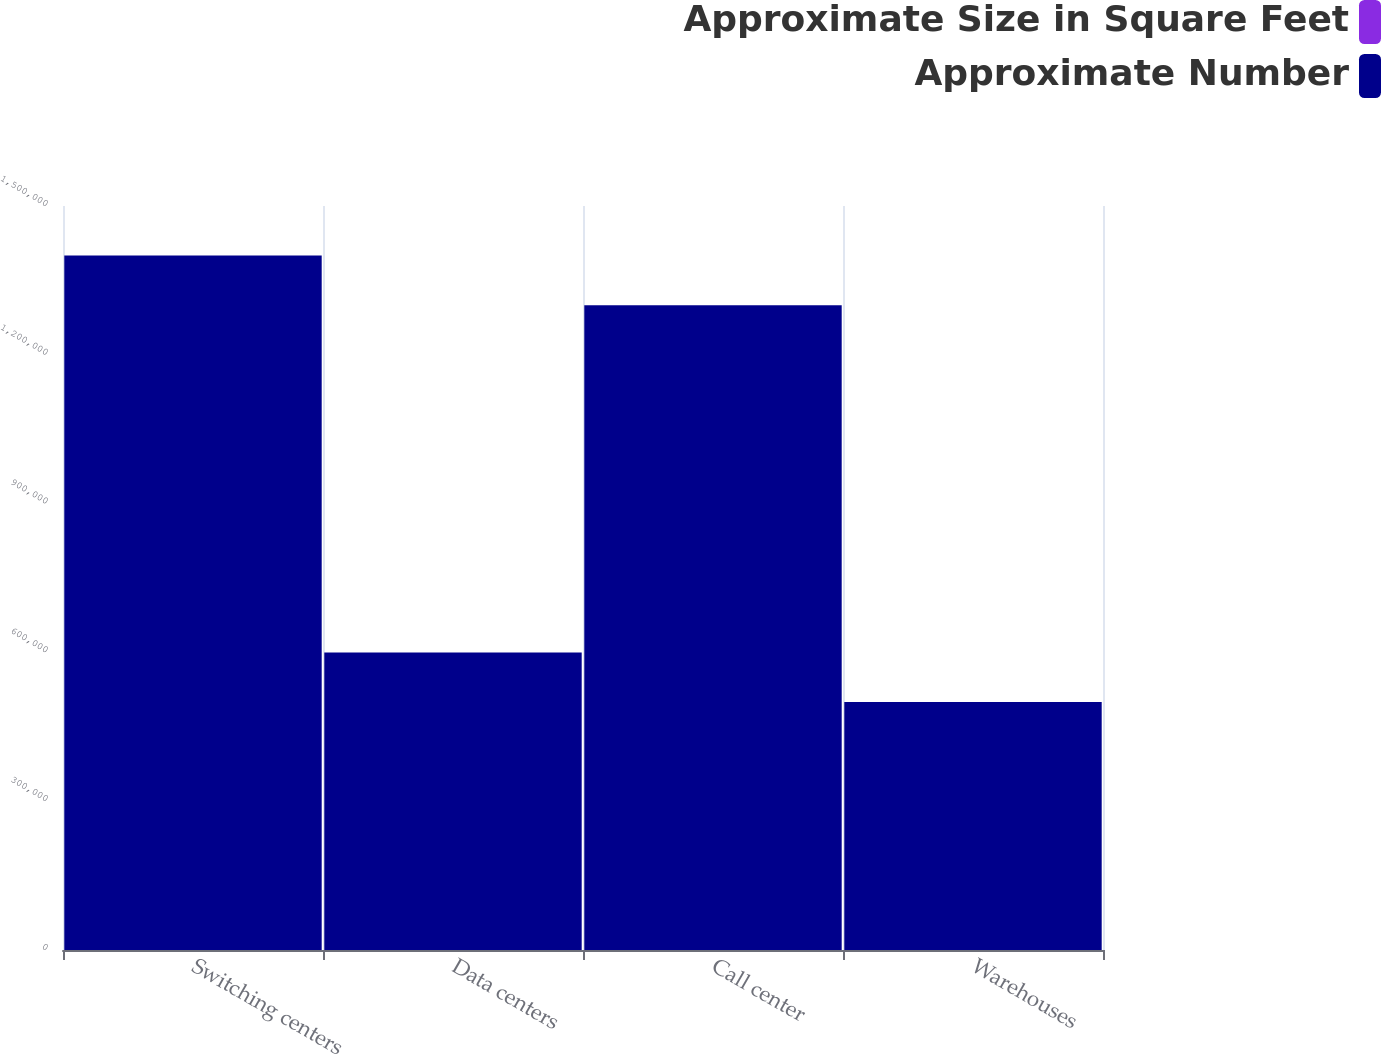Convert chart. <chart><loc_0><loc_0><loc_500><loc_500><stacked_bar_chart><ecel><fcel>Switching centers<fcel>Data centers<fcel>Call center<fcel>Warehouses<nl><fcel>Approximate Size in Square Feet<fcel>57<fcel>8<fcel>16<fcel>16<nl><fcel>Approximate Number<fcel>1.4e+06<fcel>600000<fcel>1.3e+06<fcel>500000<nl></chart> 